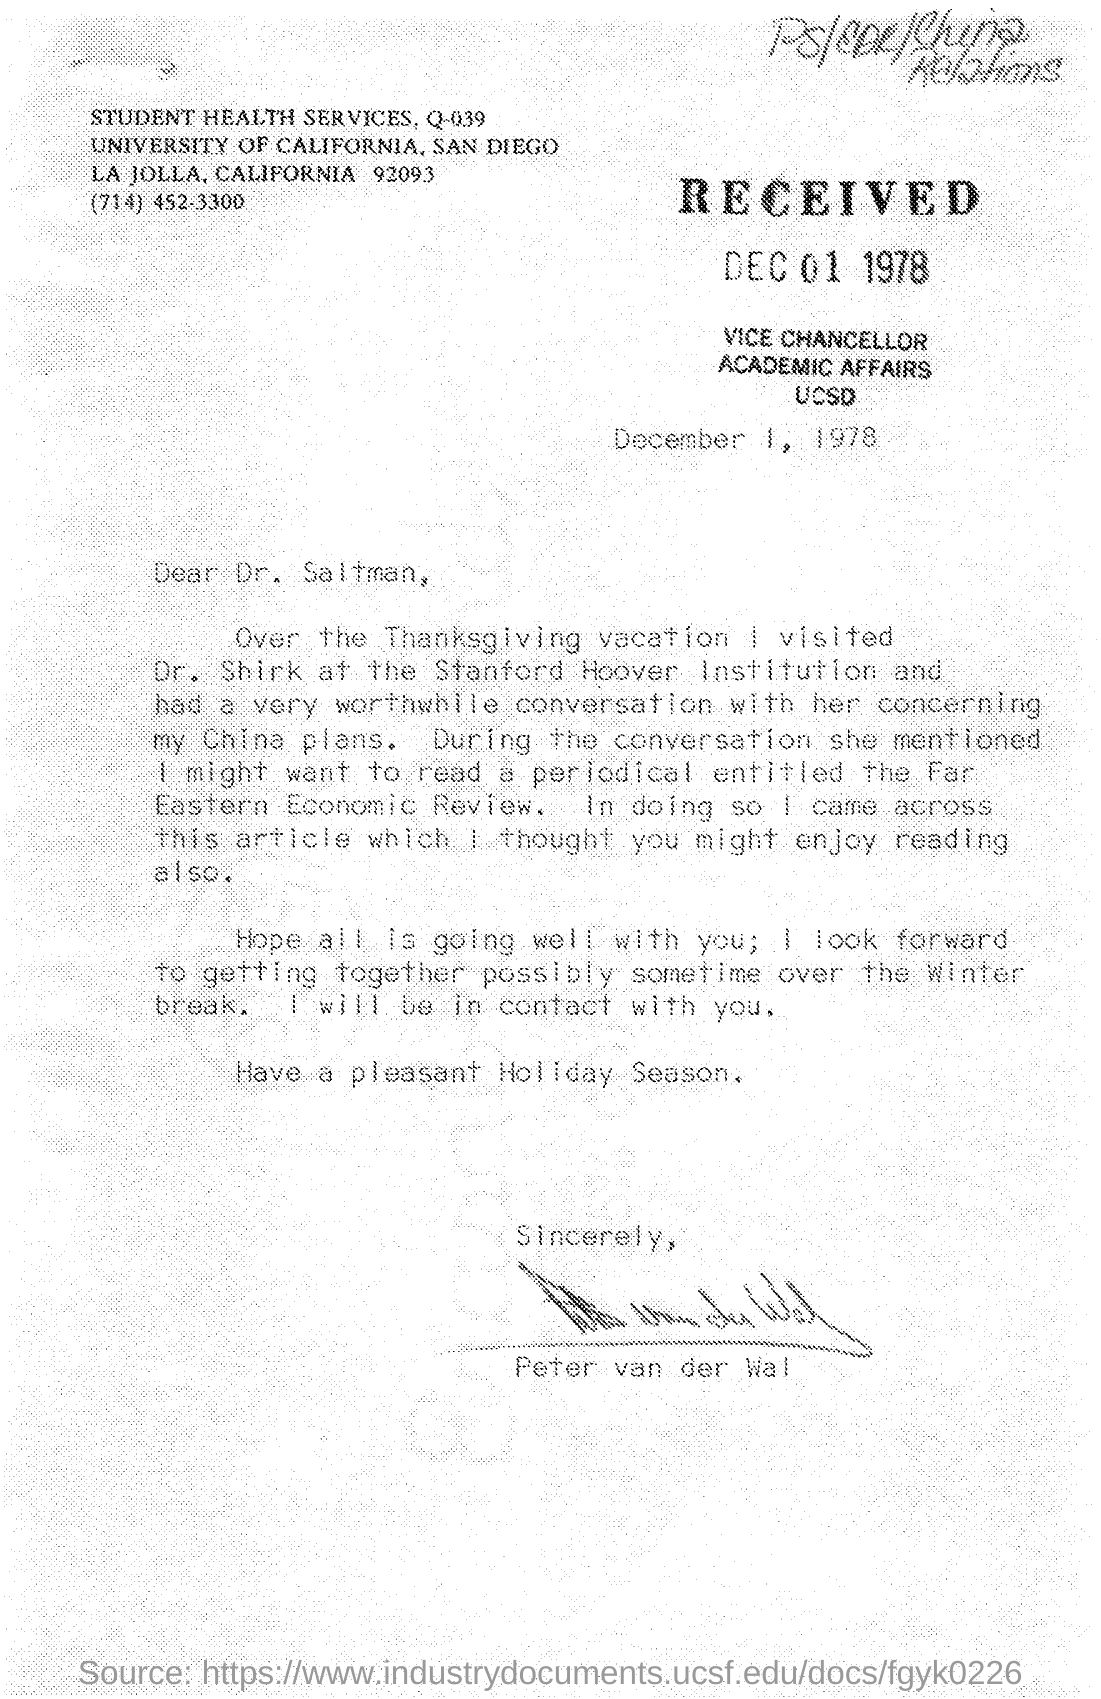On which date this letter was received ?
Make the answer very short. DEC 01 1978. On which date this letter was written ?
Offer a very short reply. December 1 , 1978. What is the name of the services mentioned in the given letter ?
Provide a succinct answer. Student health services, q-039. What is the name of the university mentioned in the given letter ?
Your answer should be compact. University of california. Who's sign was there at the end of the letter ?
Provide a short and direct response. Peter van der wal. 